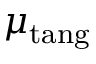Convert formula to latex. <formula><loc_0><loc_0><loc_500><loc_500>\mu _ { t a n g }</formula> 